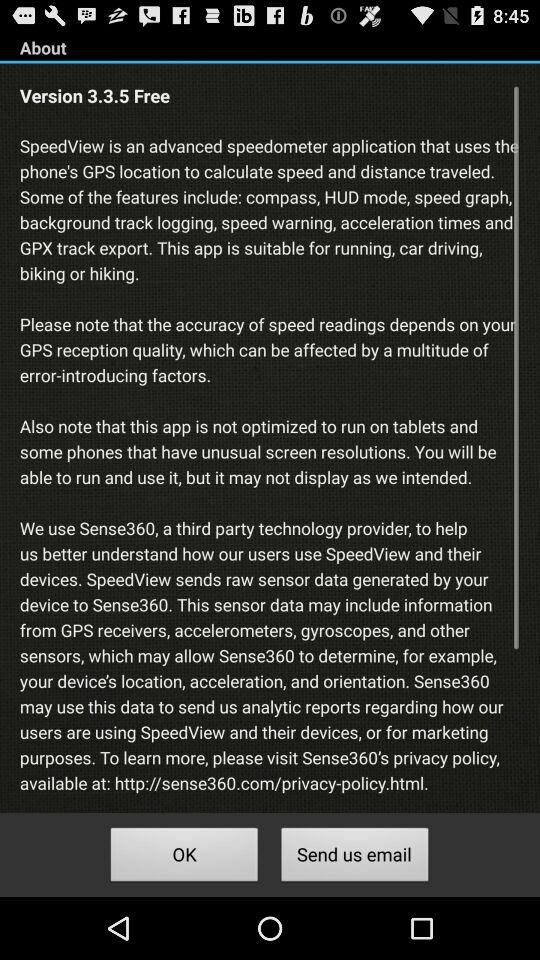What is the version of the app? The version of the app is 3.3.5. 